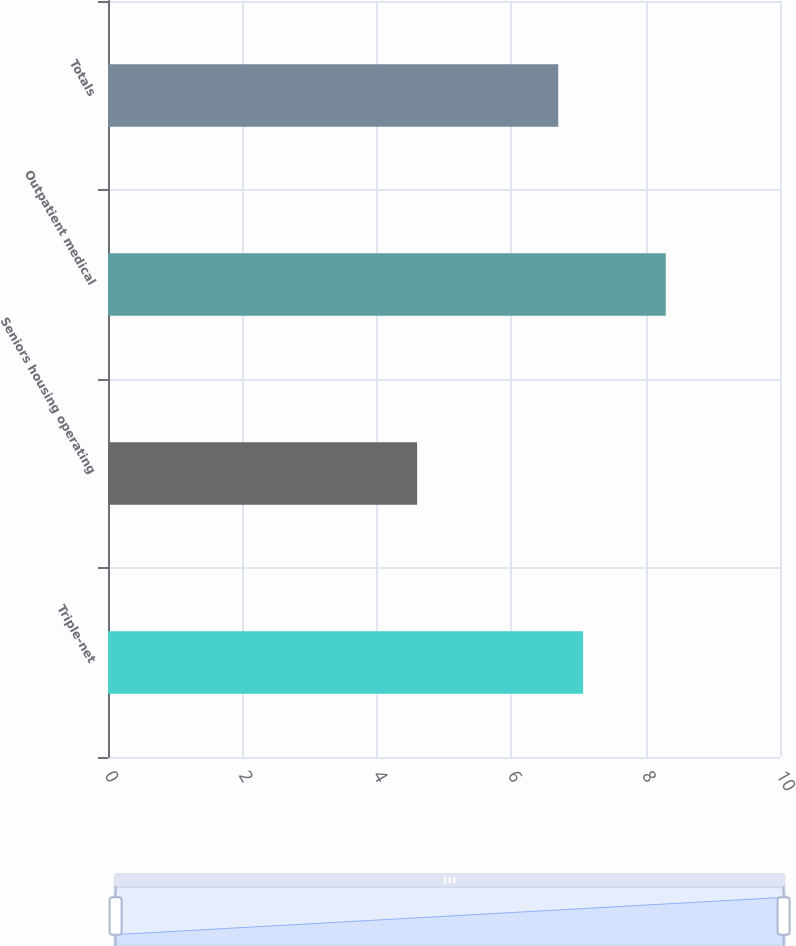Convert chart to OTSL. <chart><loc_0><loc_0><loc_500><loc_500><bar_chart><fcel>Triple-net<fcel>Seniors housing operating<fcel>Outpatient medical<fcel>Totals<nl><fcel>7.07<fcel>4.6<fcel>8.3<fcel>6.7<nl></chart> 